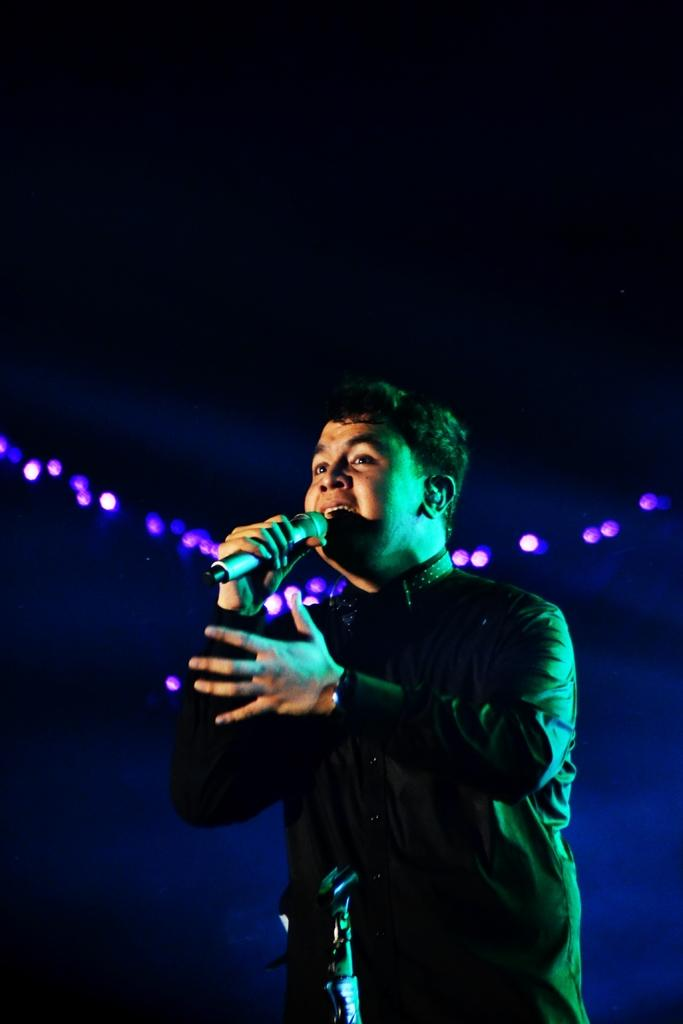Who is the main subject in the image? There is a person in the image. What is the person holding in the image? The person is holding a microphone. What is the person doing with the microphone? The person is singing. What is located at the bottom of the image? There is an object at the bottom of the image. How would you describe the lighting in the image? There are lights visible in the image. What can be inferred about the background based on the provided facts? The background of the image is dark. What type of dirt can be seen on the person's shoes in the image? There is no dirt visible on the person's shoes in the image. What event is the person attending in the image? The provided facts do not mention any specific event, so it cannot be determined from the image. 